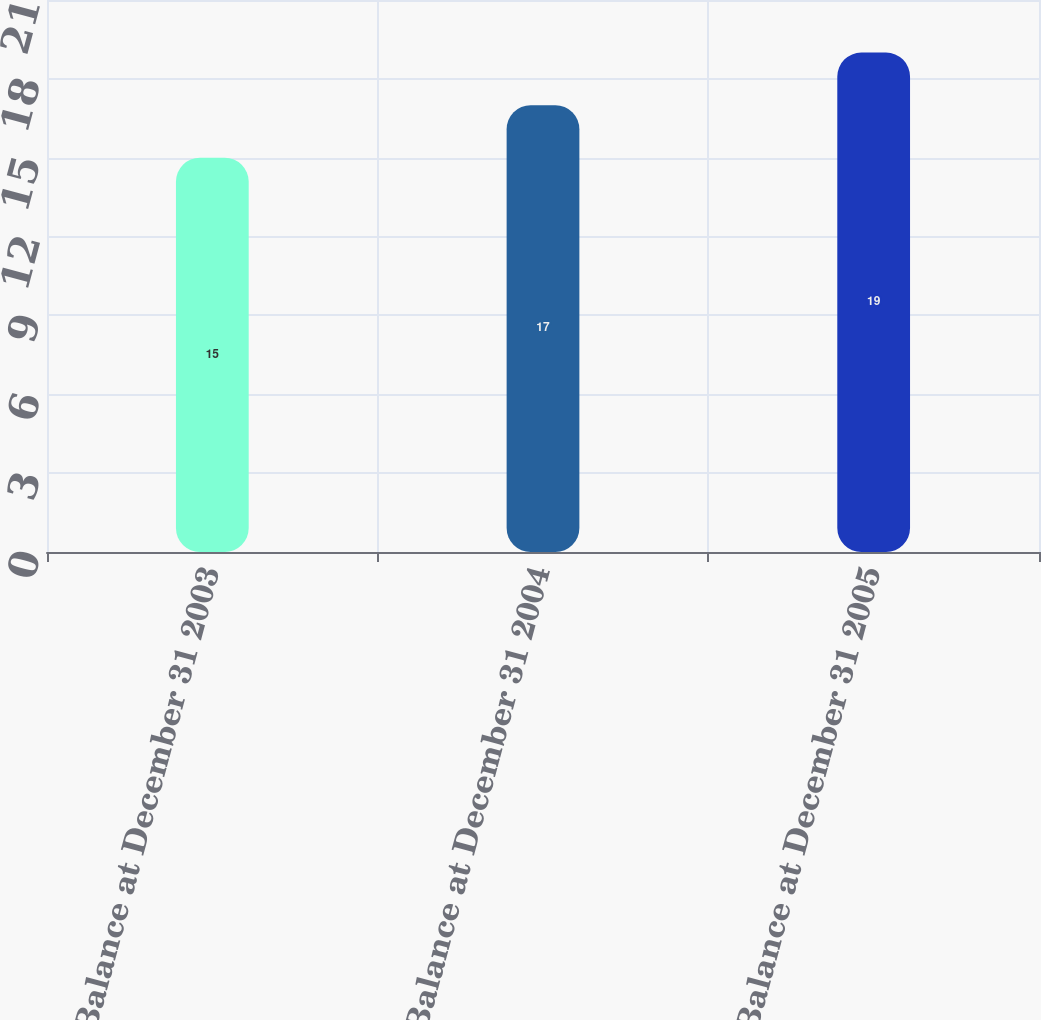Convert chart to OTSL. <chart><loc_0><loc_0><loc_500><loc_500><bar_chart><fcel>Balance at December 31 2003<fcel>Balance at December 31 2004<fcel>Balance at December 31 2005<nl><fcel>15<fcel>17<fcel>19<nl></chart> 